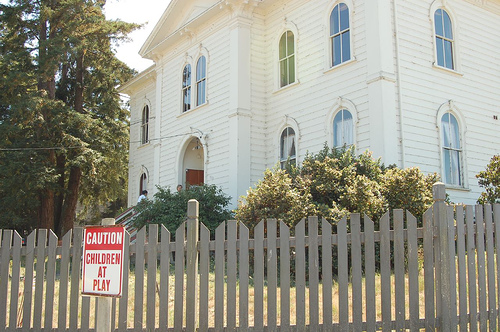<image>
Is the fence behind the tree? No. The fence is not behind the tree. From this viewpoint, the fence appears to be positioned elsewhere in the scene. Where is the sign in relation to the fencepost? Is it on the fencepost? Yes. Looking at the image, I can see the sign is positioned on top of the fencepost, with the fencepost providing support. 